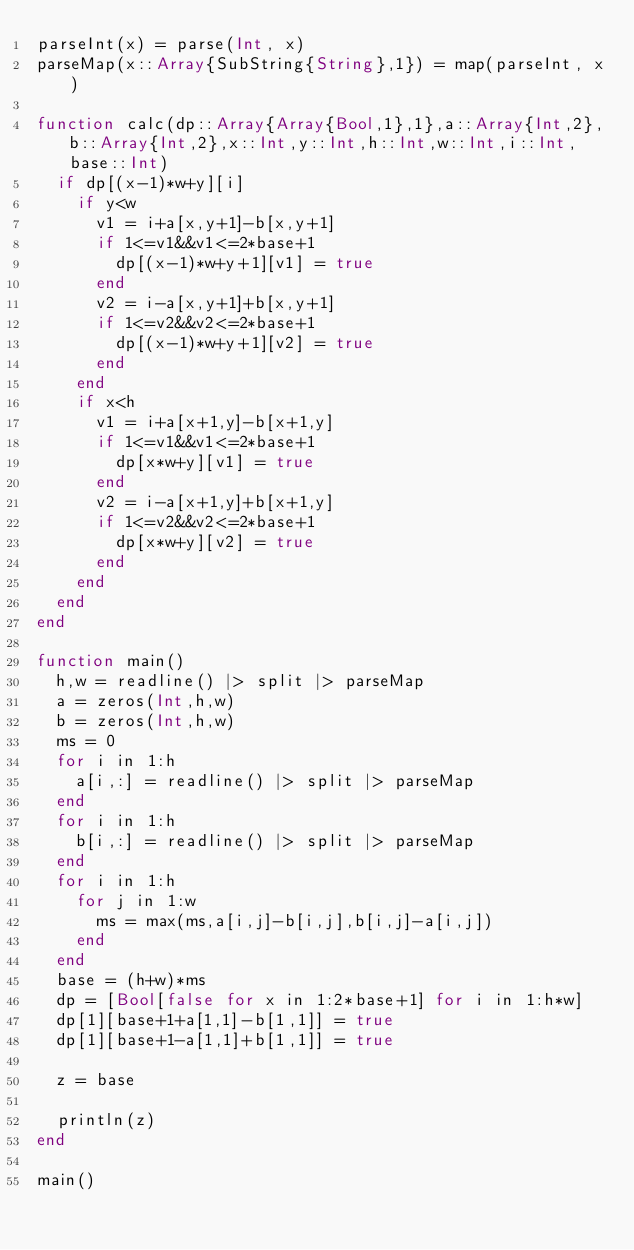Convert code to text. <code><loc_0><loc_0><loc_500><loc_500><_Julia_>parseInt(x) = parse(Int, x)
parseMap(x::Array{SubString{String},1}) = map(parseInt, x)

function calc(dp::Array{Array{Bool,1},1},a::Array{Int,2},b::Array{Int,2},x::Int,y::Int,h::Int,w::Int,i::Int,base::Int)
	if dp[(x-1)*w+y][i]
		if y<w
			v1 = i+a[x,y+1]-b[x,y+1]
			if 1<=v1&&v1<=2*base+1
				dp[(x-1)*w+y+1][v1] = true
			end
			v2 = i-a[x,y+1]+b[x,y+1]
			if 1<=v2&&v2<=2*base+1
				dp[(x-1)*w+y+1][v2] = true
			end
		end
		if x<h
			v1 = i+a[x+1,y]-b[x+1,y]
			if 1<=v1&&v1<=2*base+1
				dp[x*w+y][v1] = true
			end
			v2 = i-a[x+1,y]+b[x+1,y]
			if 1<=v2&&v2<=2*base+1
				dp[x*w+y][v2] = true
			end
		end
	end
end

function main()
	h,w = readline() |> split |> parseMap
	a = zeros(Int,h,w)
	b = zeros(Int,h,w)
	ms = 0
	for i in 1:h
		a[i,:] = readline() |> split |> parseMap
	end
	for i in 1:h
		b[i,:] = readline() |> split |> parseMap
	end
	for i in 1:h
		for j in 1:w
			ms = max(ms,a[i,j]-b[i,j],b[i,j]-a[i,j])
		end
	end
	base = (h+w)*ms
	dp = [Bool[false for x in 1:2*base+1] for i in 1:h*w]
	dp[1][base+1+a[1,1]-b[1,1]] = true
	dp[1][base+1-a[1,1]+b[1,1]] = true

	z = base

	println(z)
end

main()

</code> 